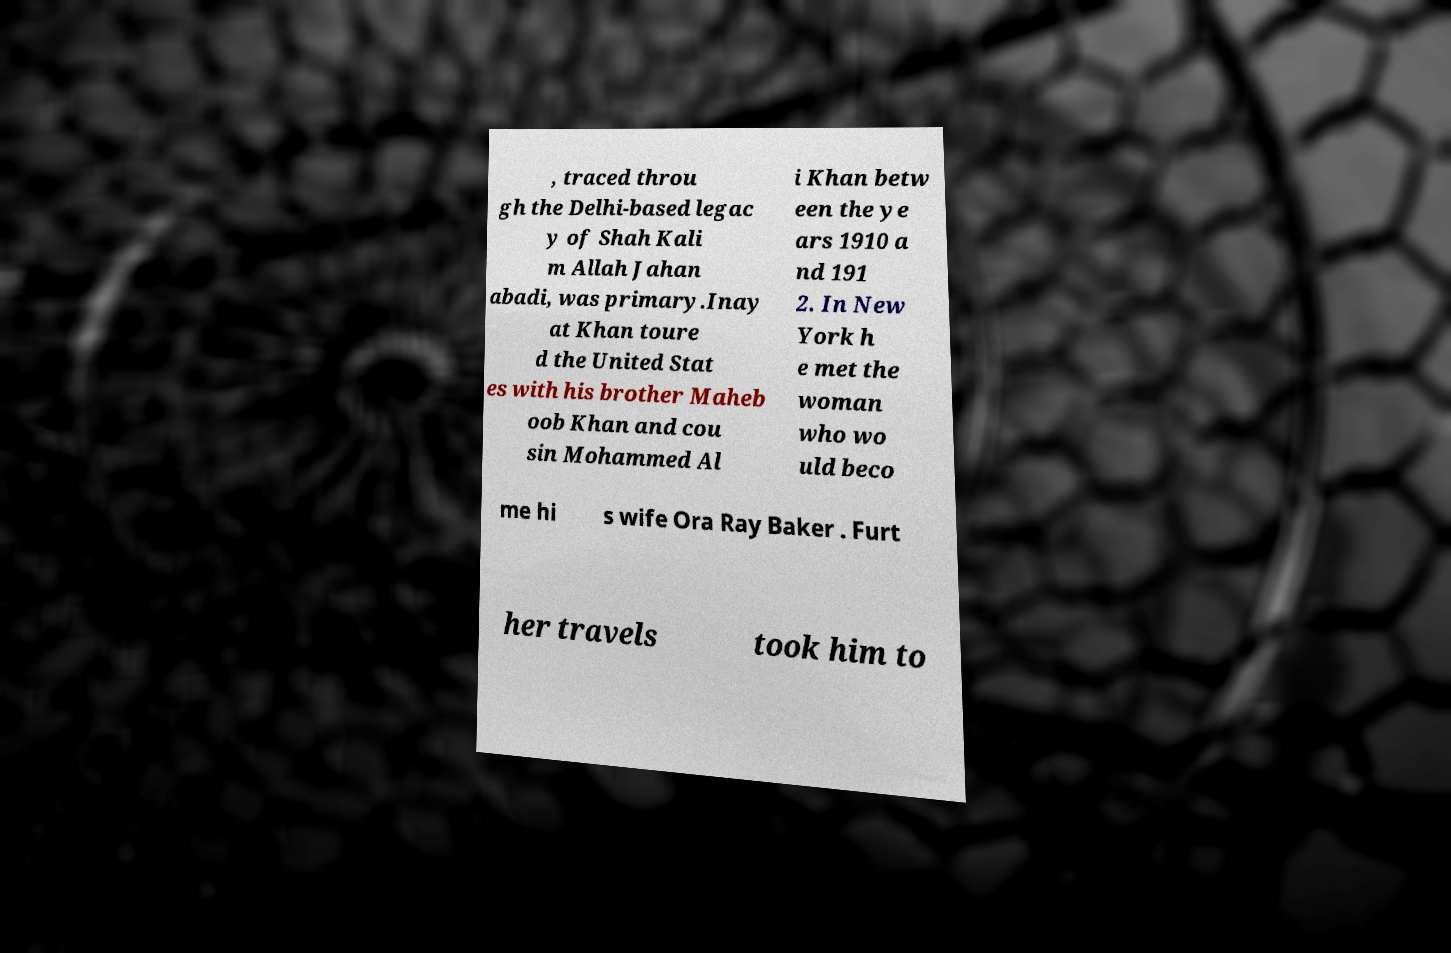Please read and relay the text visible in this image. What does it say? , traced throu gh the Delhi-based legac y of Shah Kali m Allah Jahan abadi, was primary.Inay at Khan toure d the United Stat es with his brother Maheb oob Khan and cou sin Mohammed Al i Khan betw een the ye ars 1910 a nd 191 2. In New York h e met the woman who wo uld beco me hi s wife Ora Ray Baker . Furt her travels took him to 